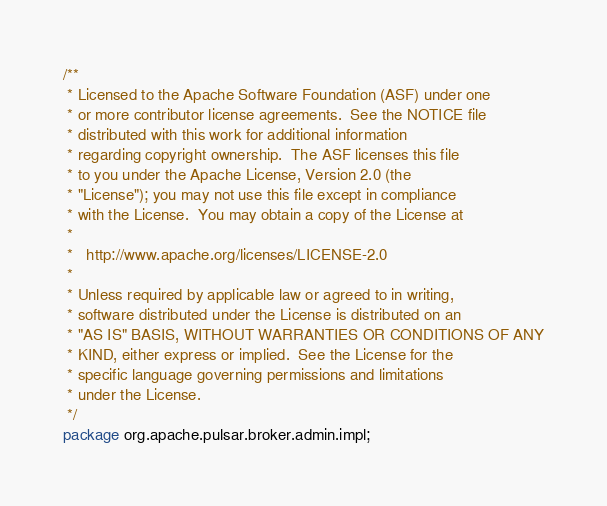<code> <loc_0><loc_0><loc_500><loc_500><_Java_>/**
 * Licensed to the Apache Software Foundation (ASF) under one
 * or more contributor license agreements.  See the NOTICE file
 * distributed with this work for additional information
 * regarding copyright ownership.  The ASF licenses this file
 * to you under the Apache License, Version 2.0 (the
 * "License"); you may not use this file except in compliance
 * with the License.  You may obtain a copy of the License at
 *
 *   http://www.apache.org/licenses/LICENSE-2.0
 *
 * Unless required by applicable law or agreed to in writing,
 * software distributed under the License is distributed on an
 * "AS IS" BASIS, WITHOUT WARRANTIES OR CONDITIONS OF ANY
 * KIND, either express or implied.  See the License for the
 * specific language governing permissions and limitations
 * under the License.
 */
package org.apache.pulsar.broker.admin.impl;
</code> 